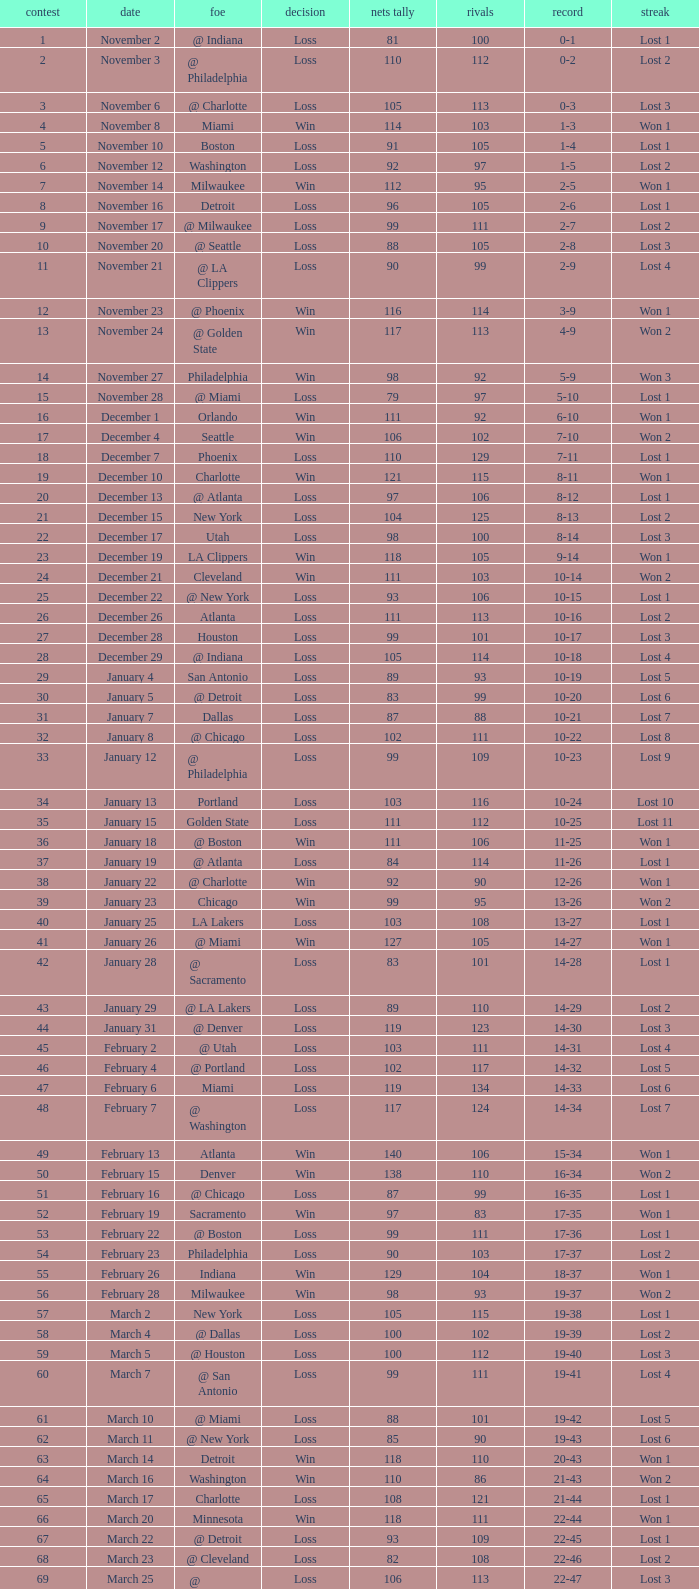Give me the full table as a dictionary. {'header': ['contest', 'date', 'foe', 'decision', 'nets tally', 'rivals', 'record', 'streak'], 'rows': [['1', 'November 2', '@ Indiana', 'Loss', '81', '100', '0-1', 'Lost 1'], ['2', 'November 3', '@ Philadelphia', 'Loss', '110', '112', '0-2', 'Lost 2'], ['3', 'November 6', '@ Charlotte', 'Loss', '105', '113', '0-3', 'Lost 3'], ['4', 'November 8', 'Miami', 'Win', '114', '103', '1-3', 'Won 1'], ['5', 'November 10', 'Boston', 'Loss', '91', '105', '1-4', 'Lost 1'], ['6', 'November 12', 'Washington', 'Loss', '92', '97', '1-5', 'Lost 2'], ['7', 'November 14', 'Milwaukee', 'Win', '112', '95', '2-5', 'Won 1'], ['8', 'November 16', 'Detroit', 'Loss', '96', '105', '2-6', 'Lost 1'], ['9', 'November 17', '@ Milwaukee', 'Loss', '99', '111', '2-7', 'Lost 2'], ['10', 'November 20', '@ Seattle', 'Loss', '88', '105', '2-8', 'Lost 3'], ['11', 'November 21', '@ LA Clippers', 'Loss', '90', '99', '2-9', 'Lost 4'], ['12', 'November 23', '@ Phoenix', 'Win', '116', '114', '3-9', 'Won 1'], ['13', 'November 24', '@ Golden State', 'Win', '117', '113', '4-9', 'Won 2'], ['14', 'November 27', 'Philadelphia', 'Win', '98', '92', '5-9', 'Won 3'], ['15', 'November 28', '@ Miami', 'Loss', '79', '97', '5-10', 'Lost 1'], ['16', 'December 1', 'Orlando', 'Win', '111', '92', '6-10', 'Won 1'], ['17', 'December 4', 'Seattle', 'Win', '106', '102', '7-10', 'Won 2'], ['18', 'December 7', 'Phoenix', 'Loss', '110', '129', '7-11', 'Lost 1'], ['19', 'December 10', 'Charlotte', 'Win', '121', '115', '8-11', 'Won 1'], ['20', 'December 13', '@ Atlanta', 'Loss', '97', '106', '8-12', 'Lost 1'], ['21', 'December 15', 'New York', 'Loss', '104', '125', '8-13', 'Lost 2'], ['22', 'December 17', 'Utah', 'Loss', '98', '100', '8-14', 'Lost 3'], ['23', 'December 19', 'LA Clippers', 'Win', '118', '105', '9-14', 'Won 1'], ['24', 'December 21', 'Cleveland', 'Win', '111', '103', '10-14', 'Won 2'], ['25', 'December 22', '@ New York', 'Loss', '93', '106', '10-15', 'Lost 1'], ['26', 'December 26', 'Atlanta', 'Loss', '111', '113', '10-16', 'Lost 2'], ['27', 'December 28', 'Houston', 'Loss', '99', '101', '10-17', 'Lost 3'], ['28', 'December 29', '@ Indiana', 'Loss', '105', '114', '10-18', 'Lost 4'], ['29', 'January 4', 'San Antonio', 'Loss', '89', '93', '10-19', 'Lost 5'], ['30', 'January 5', '@ Detroit', 'Loss', '83', '99', '10-20', 'Lost 6'], ['31', 'January 7', 'Dallas', 'Loss', '87', '88', '10-21', 'Lost 7'], ['32', 'January 8', '@ Chicago', 'Loss', '102', '111', '10-22', 'Lost 8'], ['33', 'January 12', '@ Philadelphia', 'Loss', '99', '109', '10-23', 'Lost 9'], ['34', 'January 13', 'Portland', 'Loss', '103', '116', '10-24', 'Lost 10'], ['35', 'January 15', 'Golden State', 'Loss', '111', '112', '10-25', 'Lost 11'], ['36', 'January 18', '@ Boston', 'Win', '111', '106', '11-25', 'Won 1'], ['37', 'January 19', '@ Atlanta', 'Loss', '84', '114', '11-26', 'Lost 1'], ['38', 'January 22', '@ Charlotte', 'Win', '92', '90', '12-26', 'Won 1'], ['39', 'January 23', 'Chicago', 'Win', '99', '95', '13-26', 'Won 2'], ['40', 'January 25', 'LA Lakers', 'Loss', '103', '108', '13-27', 'Lost 1'], ['41', 'January 26', '@ Miami', 'Win', '127', '105', '14-27', 'Won 1'], ['42', 'January 28', '@ Sacramento', 'Loss', '83', '101', '14-28', 'Lost 1'], ['43', 'January 29', '@ LA Lakers', 'Loss', '89', '110', '14-29', 'Lost 2'], ['44', 'January 31', '@ Denver', 'Loss', '119', '123', '14-30', 'Lost 3'], ['45', 'February 2', '@ Utah', 'Loss', '103', '111', '14-31', 'Lost 4'], ['46', 'February 4', '@ Portland', 'Loss', '102', '117', '14-32', 'Lost 5'], ['47', 'February 6', 'Miami', 'Loss', '119', '134', '14-33', 'Lost 6'], ['48', 'February 7', '@ Washington', 'Loss', '117', '124', '14-34', 'Lost 7'], ['49', 'February 13', 'Atlanta', 'Win', '140', '106', '15-34', 'Won 1'], ['50', 'February 15', 'Denver', 'Win', '138', '110', '16-34', 'Won 2'], ['51', 'February 16', '@ Chicago', 'Loss', '87', '99', '16-35', 'Lost 1'], ['52', 'February 19', 'Sacramento', 'Win', '97', '83', '17-35', 'Won 1'], ['53', 'February 22', '@ Boston', 'Loss', '99', '111', '17-36', 'Lost 1'], ['54', 'February 23', 'Philadelphia', 'Loss', '90', '103', '17-37', 'Lost 2'], ['55', 'February 26', 'Indiana', 'Win', '129', '104', '18-37', 'Won 1'], ['56', 'February 28', 'Milwaukee', 'Win', '98', '93', '19-37', 'Won 2'], ['57', 'March 2', 'New York', 'Loss', '105', '115', '19-38', 'Lost 1'], ['58', 'March 4', '@ Dallas', 'Loss', '100', '102', '19-39', 'Lost 2'], ['59', 'March 5', '@ Houston', 'Loss', '100', '112', '19-40', 'Lost 3'], ['60', 'March 7', '@ San Antonio', 'Loss', '99', '111', '19-41', 'Lost 4'], ['61', 'March 10', '@ Miami', 'Loss', '88', '101', '19-42', 'Lost 5'], ['62', 'March 11', '@ New York', 'Loss', '85', '90', '19-43', 'Lost 6'], ['63', 'March 14', 'Detroit', 'Win', '118', '110', '20-43', 'Won 1'], ['64', 'March 16', 'Washington', 'Win', '110', '86', '21-43', 'Won 2'], ['65', 'March 17', 'Charlotte', 'Loss', '108', '121', '21-44', 'Lost 1'], ['66', 'March 20', 'Minnesota', 'Win', '118', '111', '22-44', 'Won 1'], ['67', 'March 22', '@ Detroit', 'Loss', '93', '109', '22-45', 'Lost 1'], ['68', 'March 23', '@ Cleveland', 'Loss', '82', '108', '22-46', 'Lost 2'], ['69', 'March 25', '@ Washington', 'Loss', '106', '113', '22-47', 'Lost 3'], ['70', 'March 26', 'Philadelphia', 'Win', '98', '95', '23-47', 'Won 1'], ['71', 'March 28', 'Chicago', 'Loss', '94', '128', '23-48', 'Lost 1'], ['72', 'March 30', 'New York', 'Loss', '117', '130', '23-49', 'Lost 2'], ['73', 'April 2', 'Boston', 'Loss', '77', '94', '23-50', 'Lost 3'], ['74', 'April 4', '@ Boston', 'Loss', '104', '123', '23-51', 'Lost 4'], ['75', 'April 6', '@ Milwaukee', 'Loss', '114', '133', '23-52', 'Lost 5'], ['76', 'April 9', '@ Minnesota', 'Loss', '89', '109', '23-53', 'Lost 6'], ['77', 'April 12', 'Cleveland', 'Win', '104', '103', '24-53', 'Won 1'], ['78', 'April 13', '@ Cleveland', 'Loss', '98', '102', '24-54', 'Lost 1'], ['79', 'April 16', 'Indiana', 'Loss', '126', '132', '24-55', 'Lost 2'], ['80', 'April 18', '@ Washington', 'Win', '108', '103', '25-55', 'Won 1'], ['81', 'April 20', 'Miami', 'Win', '118', '103', '26-55', 'Won 2'], ['82', 'April 21', '@ Orlando', 'Loss', '110', '120', '26-56', 'Lost 1']]} In which game did the opponent score more than 103 and the record was 1-3? None. 